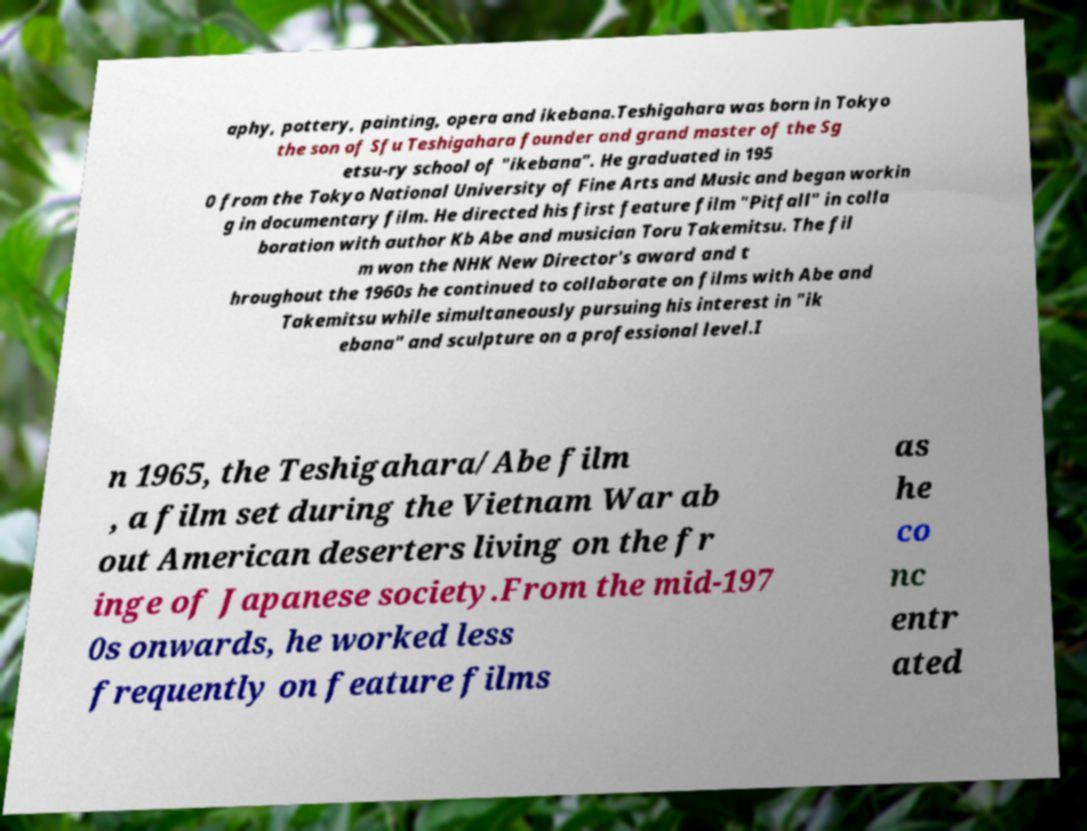Could you extract and type out the text from this image? aphy, pottery, painting, opera and ikebana.Teshigahara was born in Tokyo the son of Sfu Teshigahara founder and grand master of the Sg etsu-ry school of "ikebana". He graduated in 195 0 from the Tokyo National University of Fine Arts and Music and began workin g in documentary film. He directed his first feature film "Pitfall" in colla boration with author Kb Abe and musician Toru Takemitsu. The fil m won the NHK New Director's award and t hroughout the 1960s he continued to collaborate on films with Abe and Takemitsu while simultaneously pursuing his interest in "ik ebana" and sculpture on a professional level.I n 1965, the Teshigahara/Abe film , a film set during the Vietnam War ab out American deserters living on the fr inge of Japanese society.From the mid-197 0s onwards, he worked less frequently on feature films as he co nc entr ated 